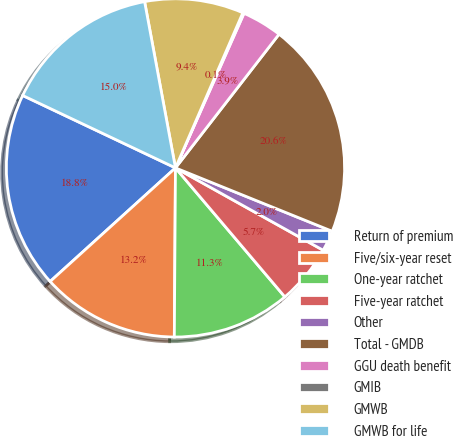Convert chart. <chart><loc_0><loc_0><loc_500><loc_500><pie_chart><fcel>Return of premium<fcel>Five/six-year reset<fcel>One-year ratchet<fcel>Five-year ratchet<fcel>Other<fcel>Total - GMDB<fcel>GGU death benefit<fcel>GMIB<fcel>GMWB<fcel>GMWB for life<nl><fcel>18.76%<fcel>13.17%<fcel>11.3%<fcel>5.71%<fcel>1.98%<fcel>20.62%<fcel>3.85%<fcel>0.12%<fcel>9.44%<fcel>15.03%<nl></chart> 